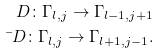Convert formula to latex. <formula><loc_0><loc_0><loc_500><loc_500>\ D \colon \Gamma _ { l , j } \to \Gamma _ { l - 1 , j + 1 } \\ \bar { \ } D \colon \Gamma _ { l , j } \to \Gamma _ { l + 1 , j - 1 } .</formula> 